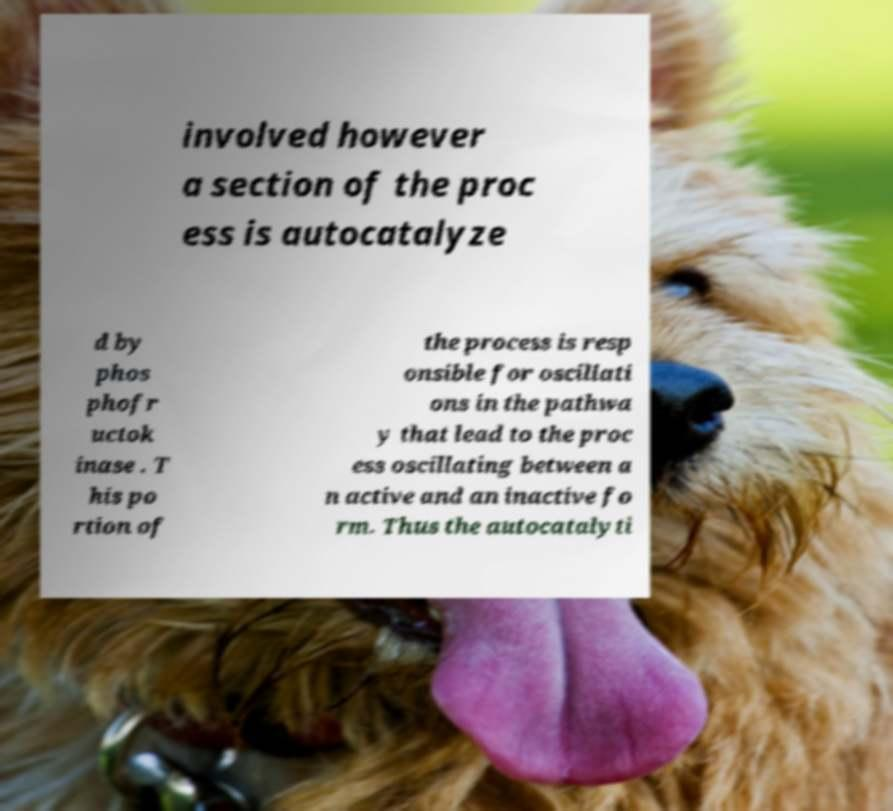There's text embedded in this image that I need extracted. Can you transcribe it verbatim? involved however a section of the proc ess is autocatalyze d by phos phofr uctok inase . T his po rtion of the process is resp onsible for oscillati ons in the pathwa y that lead to the proc ess oscillating between a n active and an inactive fo rm. Thus the autocatalyti 